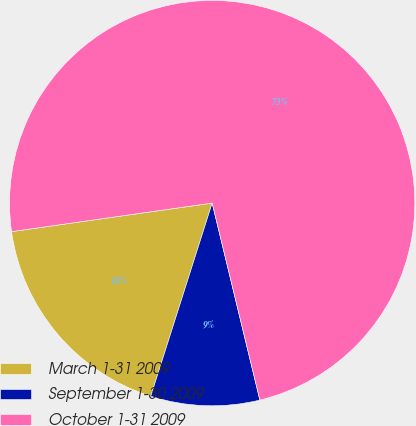Convert chart. <chart><loc_0><loc_0><loc_500><loc_500><pie_chart><fcel>March 1-31 2009<fcel>September 1-30 2009<fcel>October 1-31 2009<nl><fcel>17.85%<fcel>8.68%<fcel>73.46%<nl></chart> 